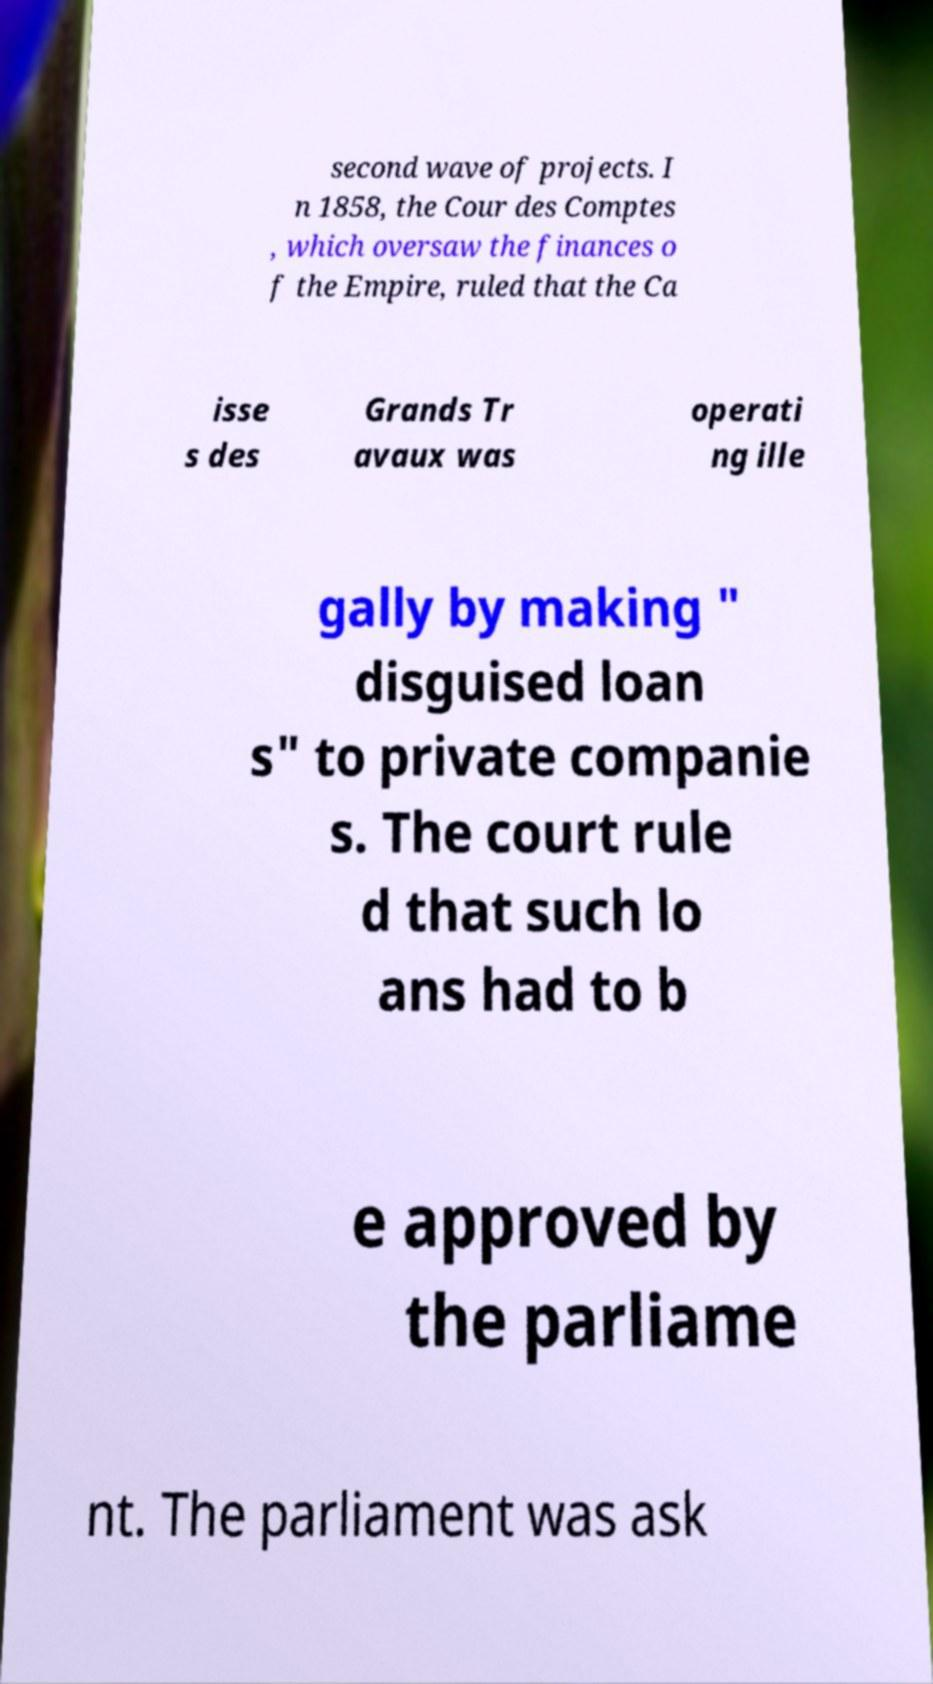What messages or text are displayed in this image? I need them in a readable, typed format. second wave of projects. I n 1858, the Cour des Comptes , which oversaw the finances o f the Empire, ruled that the Ca isse s des Grands Tr avaux was operati ng ille gally by making " disguised loan s" to private companie s. The court rule d that such lo ans had to b e approved by the parliame nt. The parliament was ask 